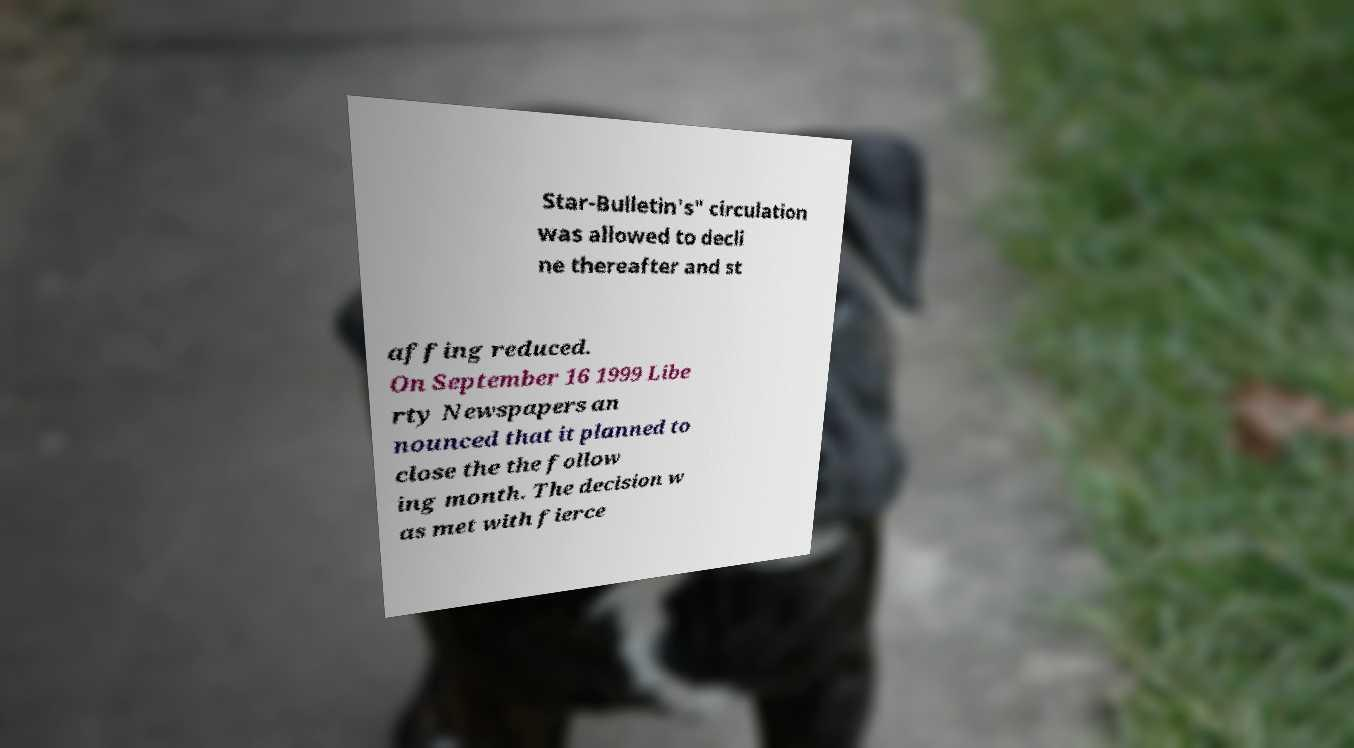Can you accurately transcribe the text from the provided image for me? Star-Bulletin's" circulation was allowed to decli ne thereafter and st affing reduced. On September 16 1999 Libe rty Newspapers an nounced that it planned to close the the follow ing month. The decision w as met with fierce 